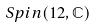<formula> <loc_0><loc_0><loc_500><loc_500>S p i n ( 1 2 , \mathbb { C } )</formula> 